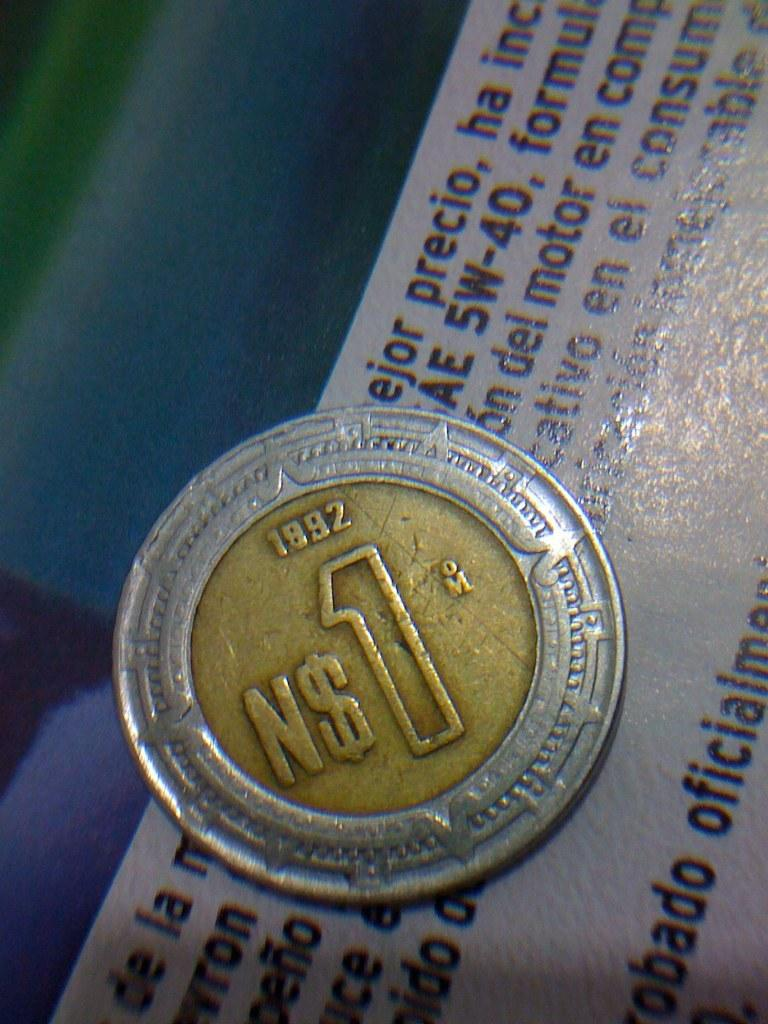Provide a one-sentence caption for the provided image. a gold coin with a silver border that reads 'N$1'. 